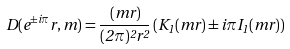<formula> <loc_0><loc_0><loc_500><loc_500>D ( e ^ { \pm i \pi } r , m ) = \frac { ( m r ) } { ( 2 \pi ) ^ { 2 } r ^ { 2 } } \left ( K _ { 1 } ( m r ) \pm i \pi I _ { 1 } ( m r ) \right )</formula> 